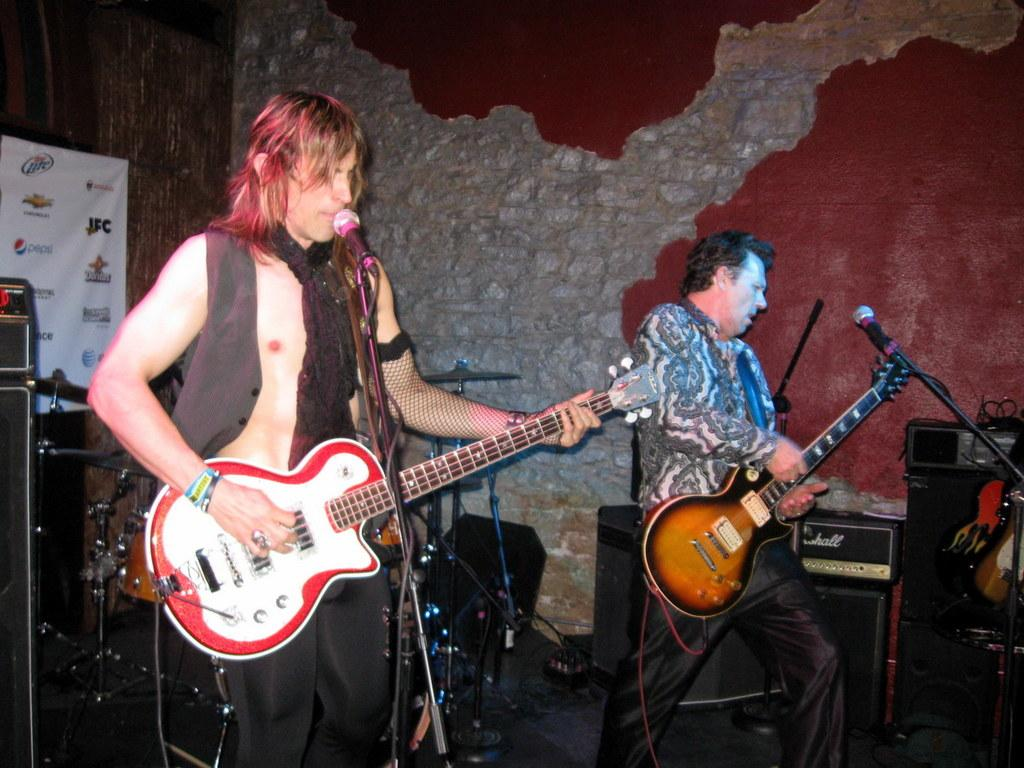How many people are in the image? There are two men in the picture. What are the men doing in the image? The men are playing guitars. What objects are in front of the men? There are microphones in front of the men. What can be seen in the background of the image? There is a wall in the background. What is attached to the wall in the background? There is a flex attached to the wall in the background. What type of sheet is covering the peace symbol in the image? There is no sheet or peace symbol present in the image. What appliance is being used by the men in the image? The men are playing guitars, which are musical instruments and not appliances. 